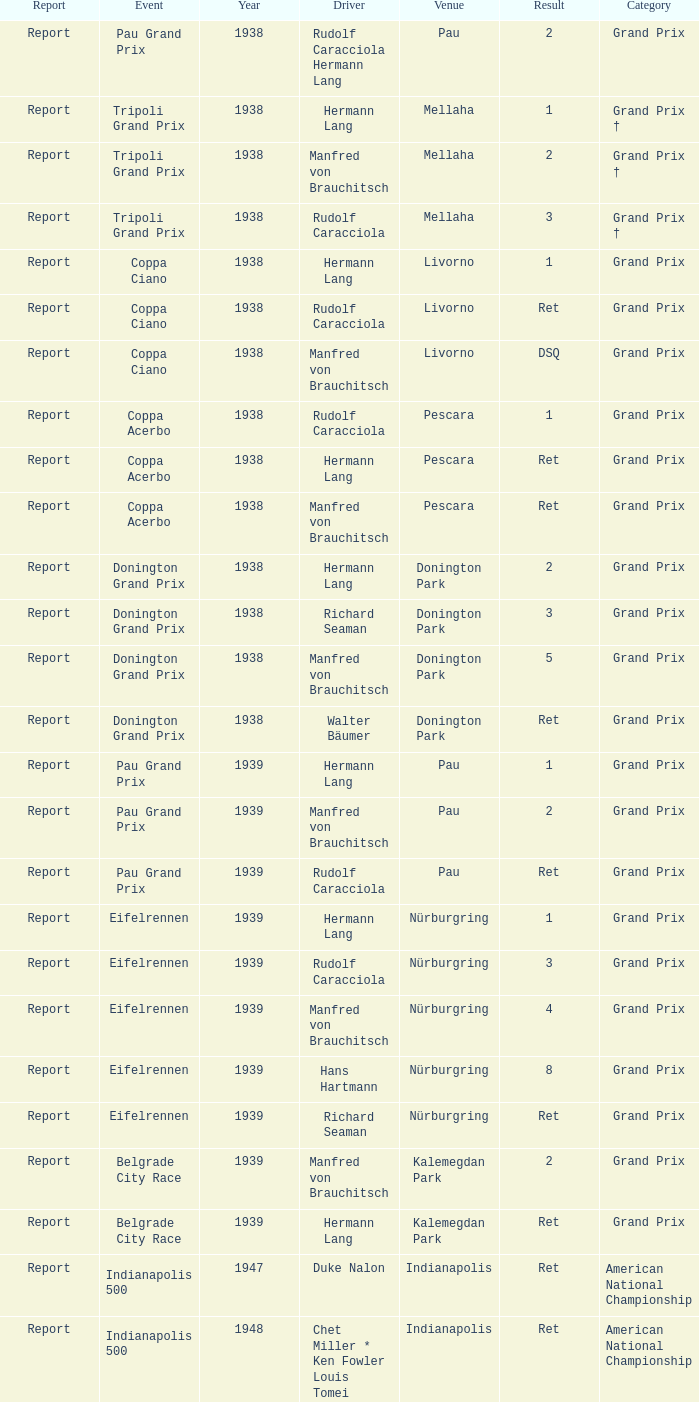When did Hans Hartmann drive? 1.0. Would you be able to parse every entry in this table? {'header': ['Report', 'Event', 'Year', 'Driver', 'Venue', 'Result', 'Category'], 'rows': [['Report', 'Pau Grand Prix', '1938', 'Rudolf Caracciola Hermann Lang', 'Pau', '2', 'Grand Prix'], ['Report', 'Tripoli Grand Prix', '1938', 'Hermann Lang', 'Mellaha', '1', 'Grand Prix †'], ['Report', 'Tripoli Grand Prix', '1938', 'Manfred von Brauchitsch', 'Mellaha', '2', 'Grand Prix †'], ['Report', 'Tripoli Grand Prix', '1938', 'Rudolf Caracciola', 'Mellaha', '3', 'Grand Prix †'], ['Report', 'Coppa Ciano', '1938', 'Hermann Lang', 'Livorno', '1', 'Grand Prix'], ['Report', 'Coppa Ciano', '1938', 'Rudolf Caracciola', 'Livorno', 'Ret', 'Grand Prix'], ['Report', 'Coppa Ciano', '1938', 'Manfred von Brauchitsch', 'Livorno', 'DSQ', 'Grand Prix'], ['Report', 'Coppa Acerbo', '1938', 'Rudolf Caracciola', 'Pescara', '1', 'Grand Prix'], ['Report', 'Coppa Acerbo', '1938', 'Hermann Lang', 'Pescara', 'Ret', 'Grand Prix'], ['Report', 'Coppa Acerbo', '1938', 'Manfred von Brauchitsch', 'Pescara', 'Ret', 'Grand Prix'], ['Report', 'Donington Grand Prix', '1938', 'Hermann Lang', 'Donington Park', '2', 'Grand Prix'], ['Report', 'Donington Grand Prix', '1938', 'Richard Seaman', 'Donington Park', '3', 'Grand Prix'], ['Report', 'Donington Grand Prix', '1938', 'Manfred von Brauchitsch', 'Donington Park', '5', 'Grand Prix'], ['Report', 'Donington Grand Prix', '1938', 'Walter Bäumer', 'Donington Park', 'Ret', 'Grand Prix'], ['Report', 'Pau Grand Prix', '1939', 'Hermann Lang', 'Pau', '1', 'Grand Prix'], ['Report', 'Pau Grand Prix', '1939', 'Manfred von Brauchitsch', 'Pau', '2', 'Grand Prix'], ['Report', 'Pau Grand Prix', '1939', 'Rudolf Caracciola', 'Pau', 'Ret', 'Grand Prix'], ['Report', 'Eifelrennen', '1939', 'Hermann Lang', 'Nürburgring', '1', 'Grand Prix'], ['Report', 'Eifelrennen', '1939', 'Rudolf Caracciola', 'Nürburgring', '3', 'Grand Prix'], ['Report', 'Eifelrennen', '1939', 'Manfred von Brauchitsch', 'Nürburgring', '4', 'Grand Prix'], ['Report', 'Eifelrennen', '1939', 'Hans Hartmann', 'Nürburgring', '8', 'Grand Prix'], ['Report', 'Eifelrennen', '1939', 'Richard Seaman', 'Nürburgring', 'Ret', 'Grand Prix'], ['Report', 'Belgrade City Race', '1939', 'Manfred von Brauchitsch', 'Kalemegdan Park', '2', 'Grand Prix'], ['Report', 'Belgrade City Race', '1939', 'Hermann Lang', 'Kalemegdan Park', 'Ret', 'Grand Prix'], ['Report', 'Indianapolis 500', '1947', 'Duke Nalon', 'Indianapolis', 'Ret', 'American National Championship'], ['Report', 'Indianapolis 500', '1948', 'Chet Miller * Ken Fowler Louis Tomei', 'Indianapolis', 'Ret', 'American National Championship'], ['Report', 'Indianapolis 500', '1949', 'Joel Thorne', 'Indianapolis', 'DNQ', 'American National Championship'], ['Report', 'Juan Peron Grand Prix', '1951', 'Hermann Lang', 'Costanera', '2', 'Formula Libre'], ['Report', 'Juan Peron Grand Prix', '1951', 'Juan Manuel Fangio', 'Costanera', '3', 'Formula Libre'], ['Report', 'Juan Peron Grand Prix', '1951', 'Karl Kling', 'Costanera', '6', 'Formula Libre'], ['Report', 'Eva Peron Grand Prix', '1951', 'Karl Kling', 'Costanera', '2', 'Formula Libre'], ['Report', 'Eva Peron Grand Prix', '1951', 'Hermann Lang', 'Costanera', '3', 'Formula Libre'], ['Report', 'Eva Peron Grand Prix', '1951', 'Juan Manuel Fangio', 'Costanera', 'Ret', 'Formula Libre'], ['Report', 'Indianapolis 500', '1957', 'Danny Kladis', 'Indianapolis', 'DNQ', 'American National Championship']]} 